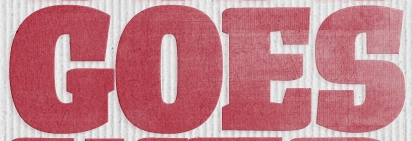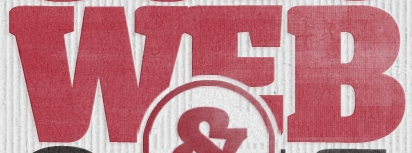What text is displayed in these images sequentially, separated by a semicolon? GOES; WEB 